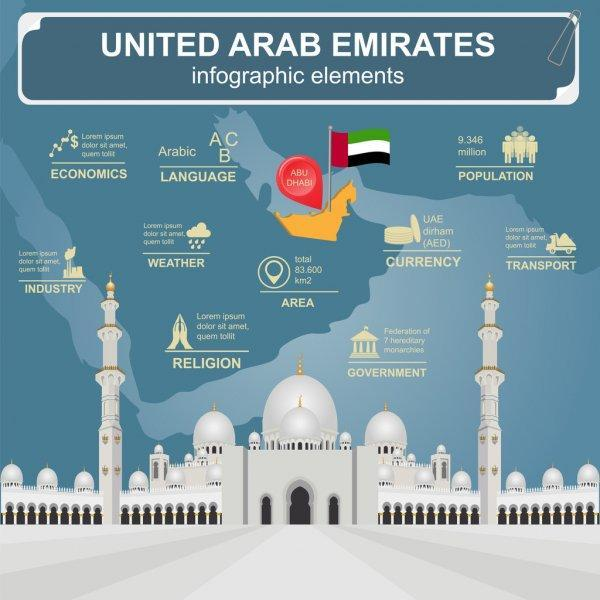What is the official language in the United Arab Emirates?
Answer the question with a short phrase. Arabic What is the capital of United Arab Emirates? ABU DHABI what is the currency of the United Arab Emirates? UAE Dirham (AED) What is the population of the United Arab Emirates? 9.436 Million What is the total area of the United Arab Emirates? 83,600 km2 